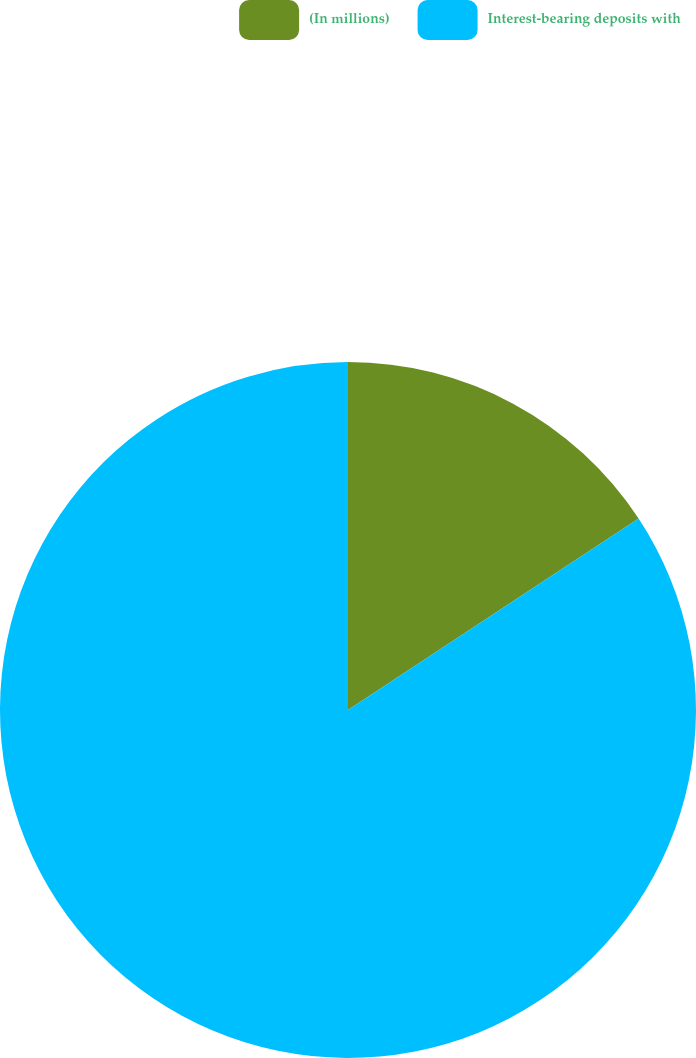Convert chart to OTSL. <chart><loc_0><loc_0><loc_500><loc_500><pie_chart><fcel>(In millions)<fcel>Interest-bearing deposits with<nl><fcel>15.73%<fcel>84.27%<nl></chart> 